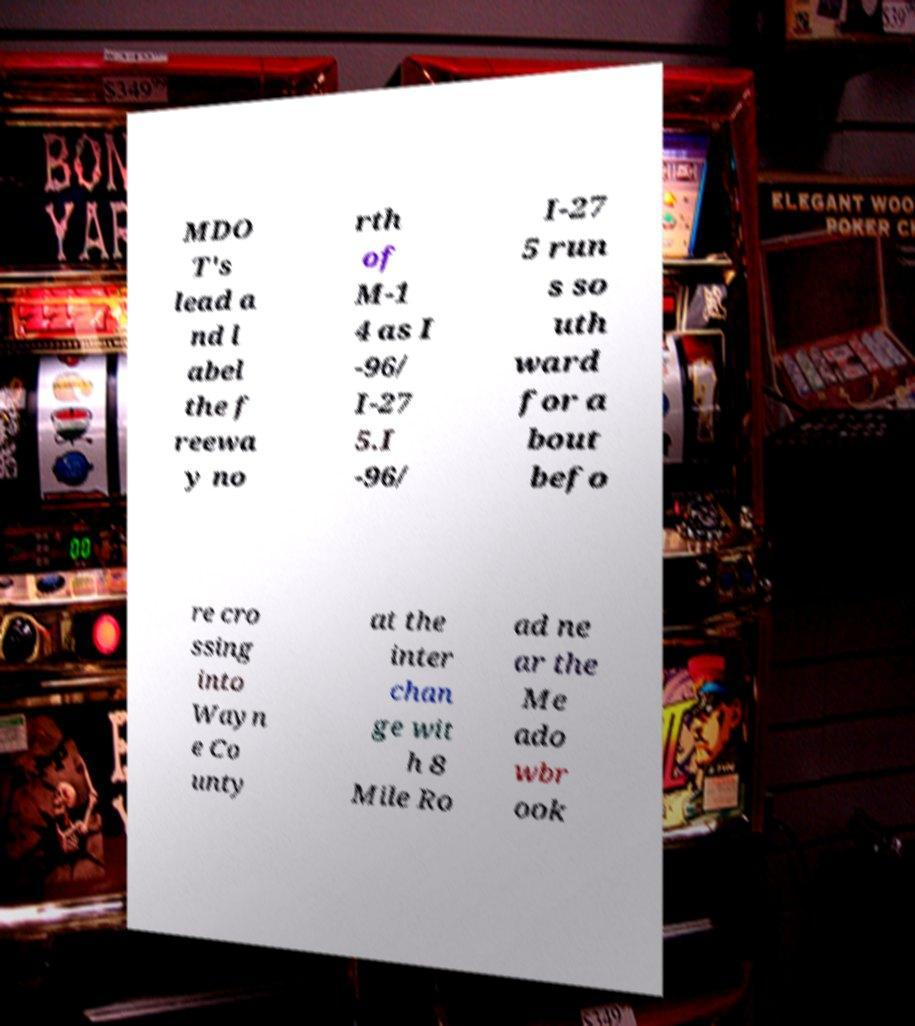Please read and relay the text visible in this image. What does it say? MDO T's lead a nd l abel the f reewa y no rth of M-1 4 as I -96/ I-27 5.I -96/ I-27 5 run s so uth ward for a bout befo re cro ssing into Wayn e Co unty at the inter chan ge wit h 8 Mile Ro ad ne ar the Me ado wbr ook 